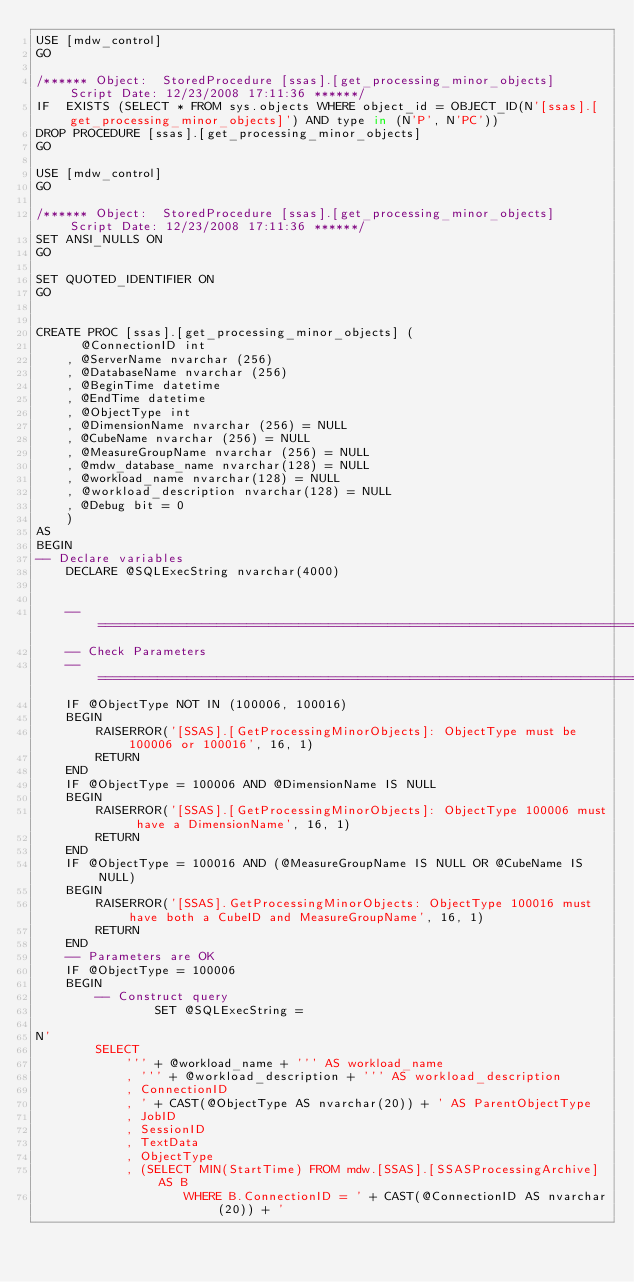<code> <loc_0><loc_0><loc_500><loc_500><_SQL_>USE [mdw_control]
GO

/****** Object:  StoredProcedure [ssas].[get_processing_minor_objects]    Script Date: 12/23/2008 17:11:36 ******/
IF  EXISTS (SELECT * FROM sys.objects WHERE object_id = OBJECT_ID(N'[ssas].[get_processing_minor_objects]') AND type in (N'P', N'PC'))
DROP PROCEDURE [ssas].[get_processing_minor_objects]
GO

USE [mdw_control]
GO

/****** Object:  StoredProcedure [ssas].[get_processing_minor_objects]    Script Date: 12/23/2008 17:11:36 ******/
SET ANSI_NULLS ON
GO

SET QUOTED_IDENTIFIER ON
GO


CREATE PROC [ssas].[get_processing_minor_objects] (
      @ConnectionID int 
    , @ServerName nvarchar (256) 
    , @DatabaseName nvarchar (256) 
    , @BeginTime datetime 
    , @EndTime datetime 
    , @ObjectType int 
    , @DimensionName nvarchar (256) = NULL
    , @CubeName nvarchar (256) = NULL
    , @MeasureGroupName nvarchar (256) = NULL
    , @mdw_database_name nvarchar(128) = NULL
    , @workload_name nvarchar(128) = NULL
    , @workload_description nvarchar(128) = NULL
    , @Debug bit = 0
    )
AS
BEGIN
-- Declare variables
    DECLARE @SQLExecString nvarchar(4000)


	-- =============================================================================
	-- Check Parameters
	-- =============================================================================
	IF @ObjectType NOT IN (100006, 100016)
	BEGIN
		RAISERROR('[SSAS].[GetProcessingMinorObjects]: ObjectType must be 100006 or 100016', 16, 1)
		RETURN
	END
	IF @ObjectType = 100006 AND @DimensionName IS NULL
	BEGIN
		RAISERROR('[SSAS].[GetProcessingMinorObjects]: ObjectType 100006 must have a DimensionName', 16, 1)
		RETURN
	END
	IF @ObjectType = 100016 AND (@MeasureGroupName IS NULL OR @CubeName IS NULL)
	BEGIN
		RAISERROR('[SSAS].GetProcessingMinorObjects: ObjectType 100016 must have both a CubeID and MeasureGroupName', 16, 1)
		RETURN
	END
	-- Parameters are OK
	IF @ObjectType = 100006
	BEGIN
	    -- Construct query
	    	    SET @SQLExecString = 

N'	
		SELECT
			''' + @workload_name + ''' AS workload_name
			, ''' + @workload_description + ''' AS workload_description
			, ConnectionID
			, ' + CAST(@ObjectType AS nvarchar(20)) + ' AS ParentObjectType
			, JobID 
			, SessionID
			, TextData
			, ObjectType
			, (SELECT MIN(StartTime) FROM mdw.[SSAS].[SSASProcessingArchive] AS B 
					WHERE B.ConnectionID = ' + CAST(@ConnectionID AS nvarchar(20)) + ' </code> 